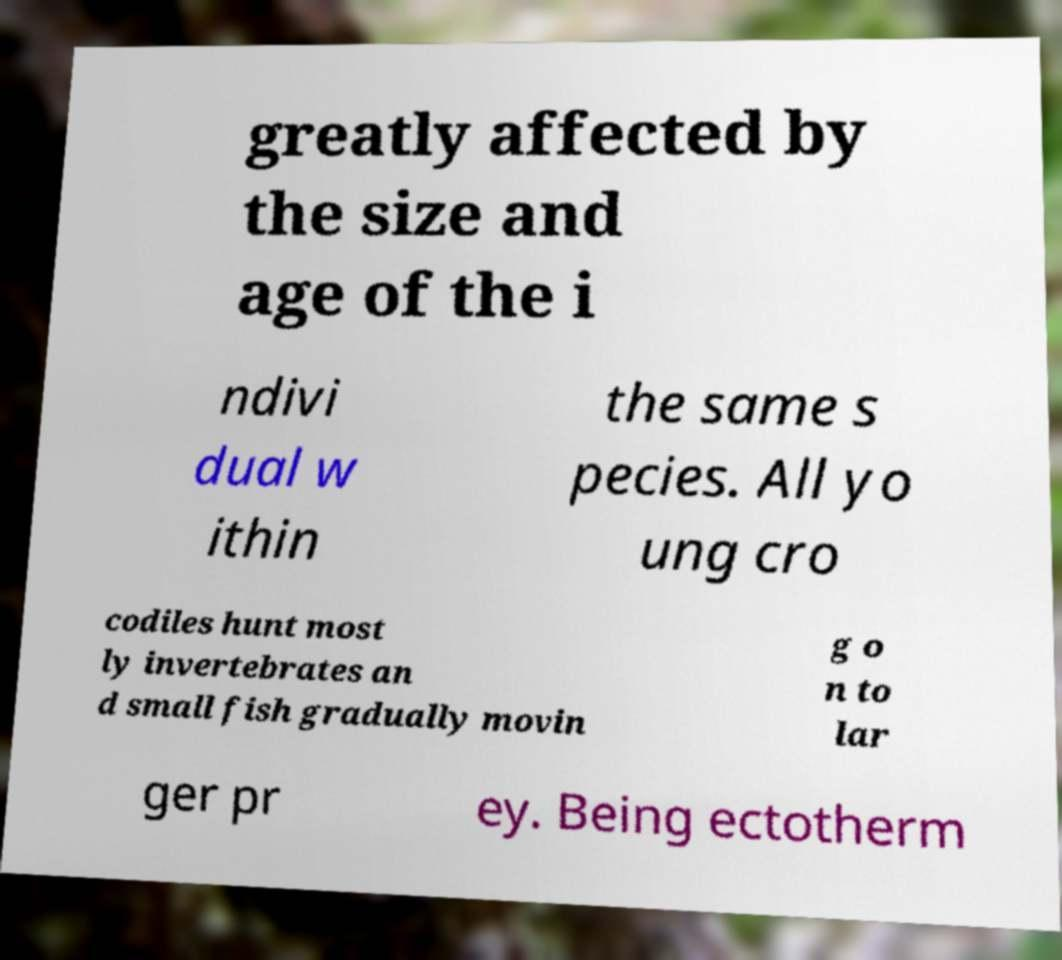Please read and relay the text visible in this image. What does it say? greatly affected by the size and age of the i ndivi dual w ithin the same s pecies. All yo ung cro codiles hunt most ly invertebrates an d small fish gradually movin g o n to lar ger pr ey. Being ectotherm 